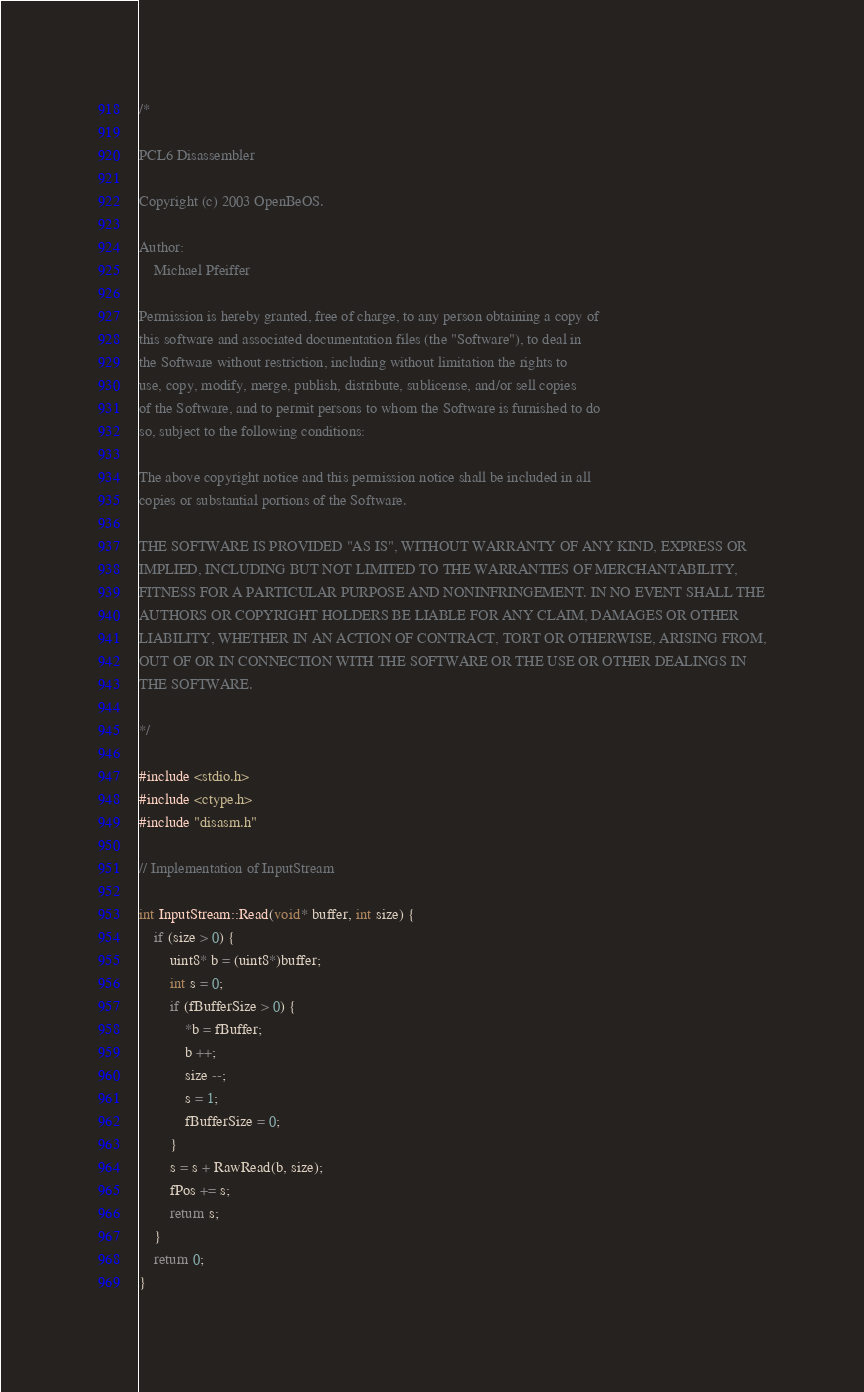Convert code to text. <code><loc_0><loc_0><loc_500><loc_500><_C++_>/*

PCL6 Disassembler

Copyright (c) 2003 OpenBeOS. 

Author: 
	Michael Pfeiffer

Permission is hereby granted, free of charge, to any person obtaining a copy of
this software and associated documentation files (the "Software"), to deal in
the Software without restriction, including without limitation the rights to
use, copy, modify, merge, publish, distribute, sublicense, and/or sell copies
of the Software, and to permit persons to whom the Software is furnished to do
so, subject to the following conditions:

The above copyright notice and this permission notice shall be included in all
copies or substantial portions of the Software.

THE SOFTWARE IS PROVIDED "AS IS", WITHOUT WARRANTY OF ANY KIND, EXPRESS OR
IMPLIED, INCLUDING BUT NOT LIMITED TO THE WARRANTIES OF MERCHANTABILITY,
FITNESS FOR A PARTICULAR PURPOSE AND NONINFRINGEMENT. IN NO EVENT SHALL THE
AUTHORS OR COPYRIGHT HOLDERS BE LIABLE FOR ANY CLAIM, DAMAGES OR OTHER
LIABILITY, WHETHER IN AN ACTION OF CONTRACT, TORT OR OTHERWISE, ARISING FROM,
OUT OF OR IN CONNECTION WITH THE SOFTWARE OR THE USE OR OTHER DEALINGS IN
THE SOFTWARE.

*/

#include <stdio.h>
#include <ctype.h>
#include "disasm.h"

// Implementation of InputStream

int InputStream::Read(void* buffer, int size) {
	if (size > 0) {
		uint8* b = (uint8*)buffer;
		int s = 0;
		if (fBufferSize > 0) {
			*b = fBuffer;
			b ++;
			size --;
			s = 1;
			fBufferSize = 0;
		}
		s = s + RawRead(b, size);
		fPos += s;
		return s;
	}
	return 0;
}
</code> 